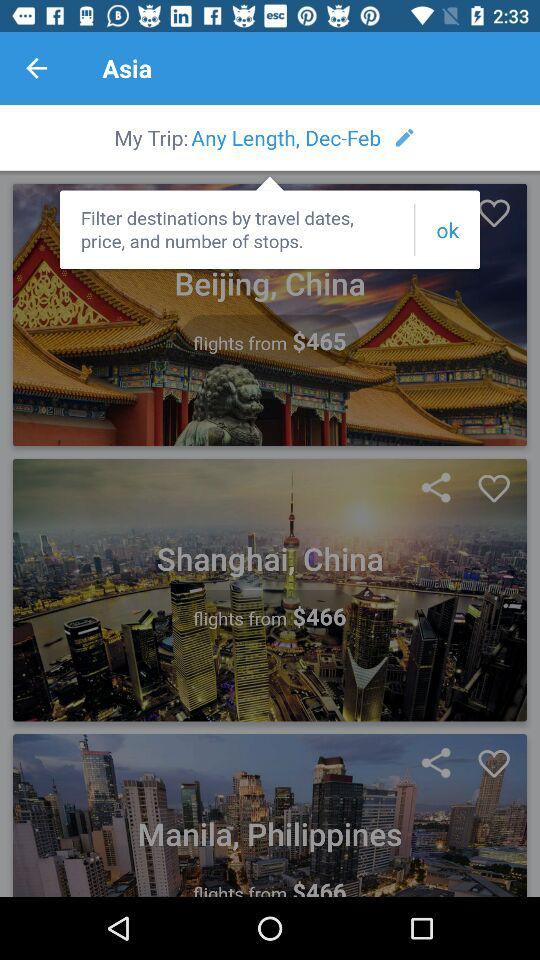What is the selected date?
When the provided information is insufficient, respond with <no answer>. <no answer> 